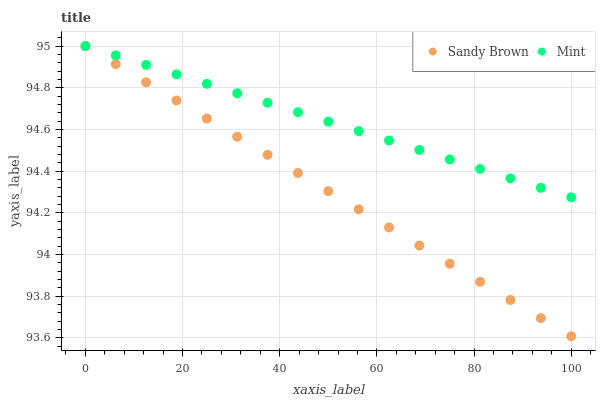Does Sandy Brown have the minimum area under the curve?
Answer yes or no. Yes. Does Mint have the maximum area under the curve?
Answer yes or no. Yes. Does Sandy Brown have the maximum area under the curve?
Answer yes or no. No. Is Mint the smoothest?
Answer yes or no. Yes. Is Sandy Brown the roughest?
Answer yes or no. Yes. Is Sandy Brown the smoothest?
Answer yes or no. No. Does Sandy Brown have the lowest value?
Answer yes or no. Yes. Does Sandy Brown have the highest value?
Answer yes or no. Yes. Does Mint intersect Sandy Brown?
Answer yes or no. Yes. Is Mint less than Sandy Brown?
Answer yes or no. No. Is Mint greater than Sandy Brown?
Answer yes or no. No. 